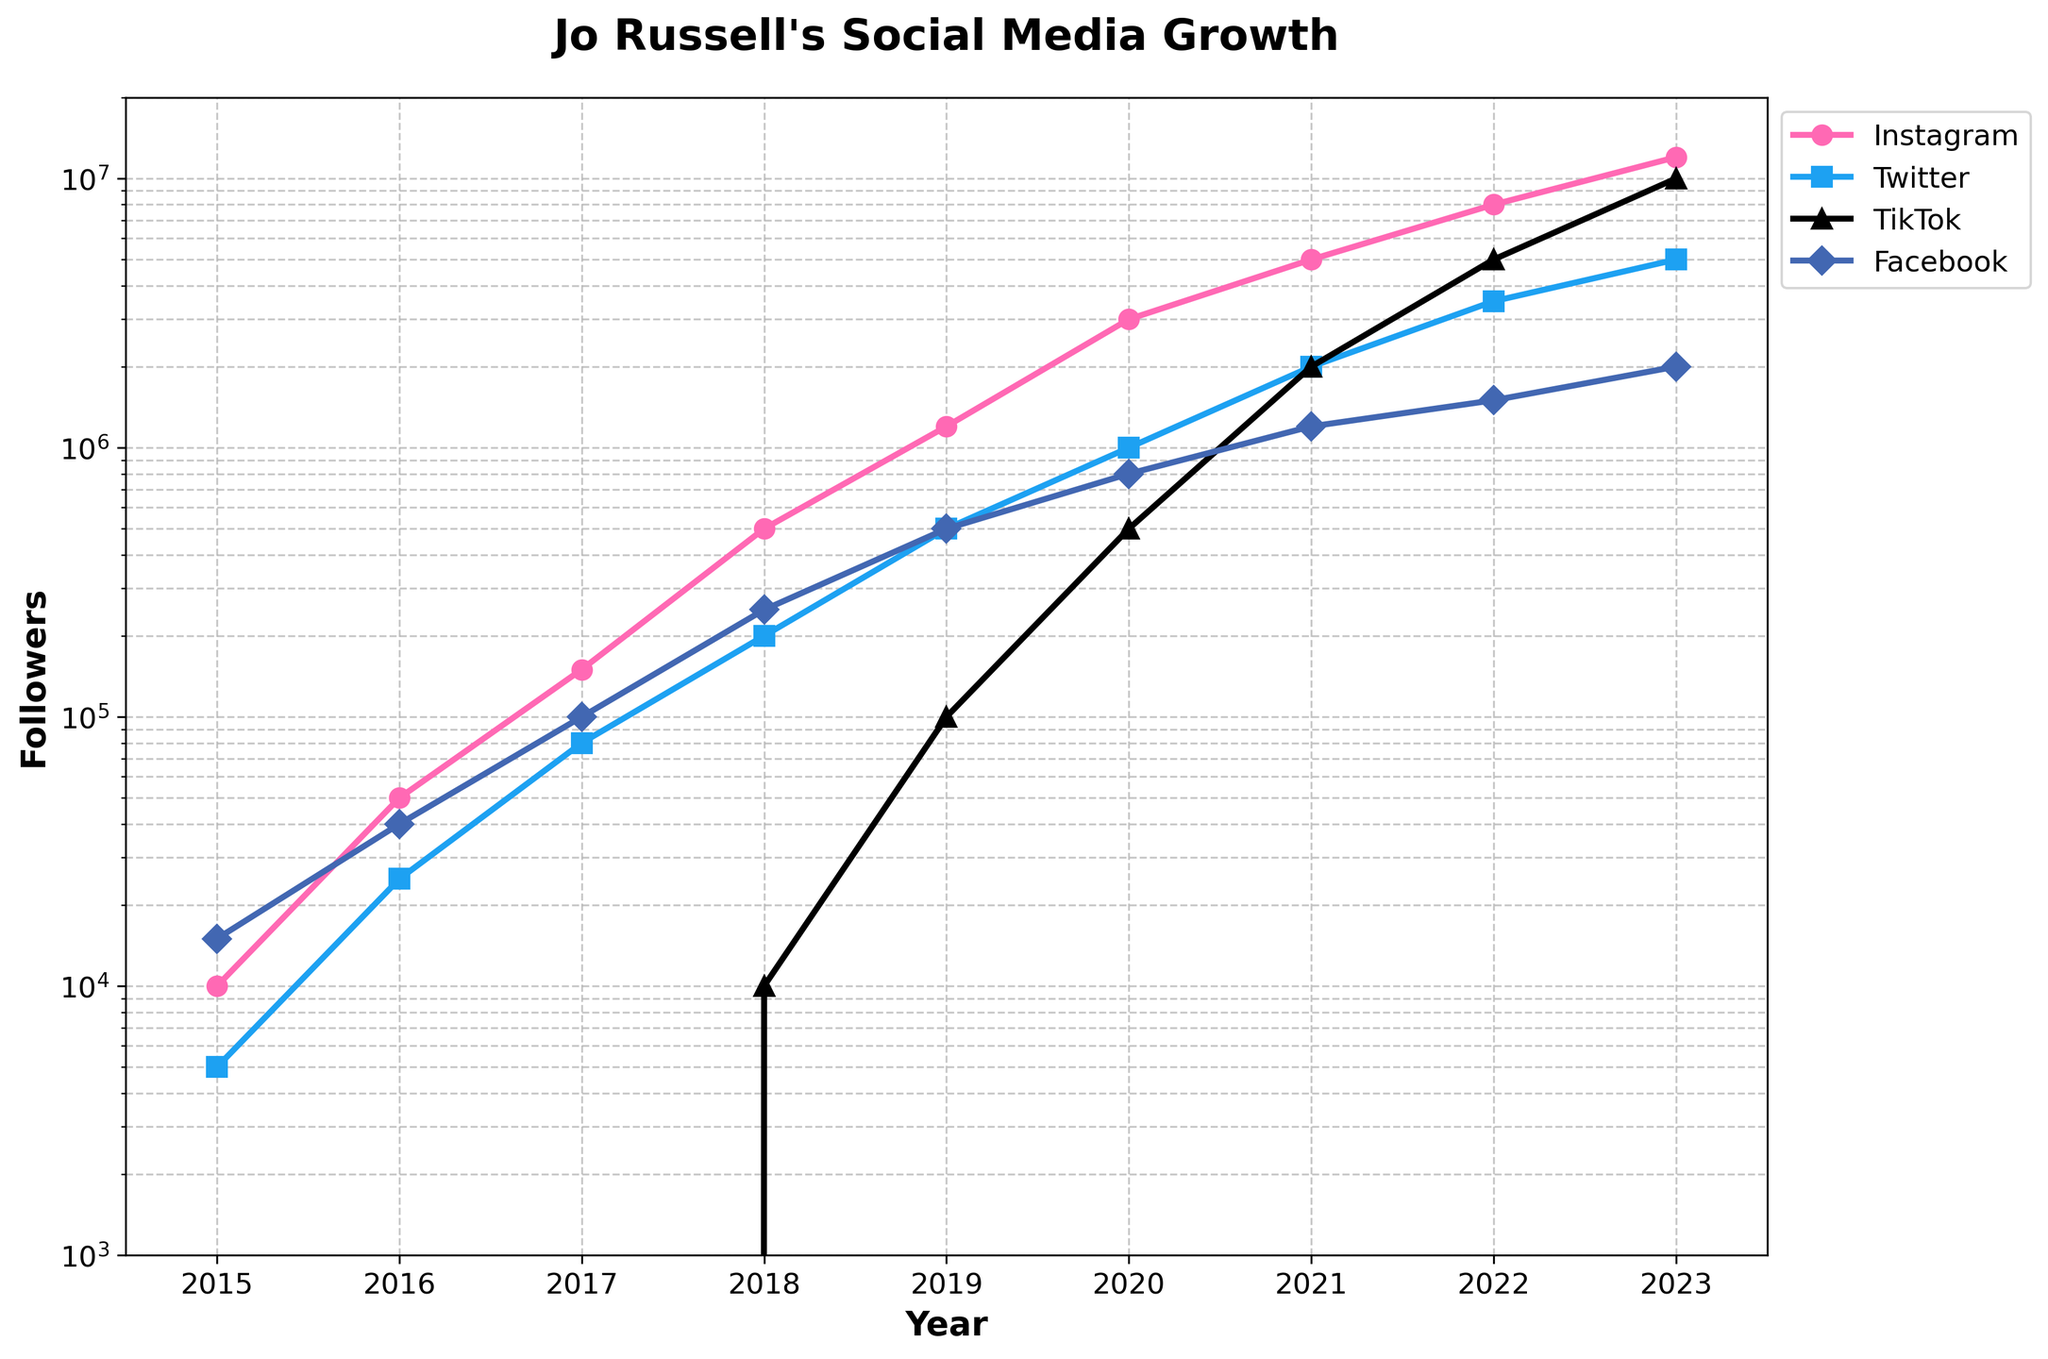what is the total number of Instagram followers Jo Russell had in 2018 and 2020 combined? In 2018, Jo had 500,000 Instagram followers, and in 2020, she had 3,000,000. Adding these together, 500,000 + 3,000,000 = 3,500,000.
Answer: 3,500,000 Which platform saw the highest follower count in 2023? In the year 2023, TikTok had the highest follower count, reaching 10,000,000 followers according to the chart.
Answer: TikTok Between Twitter and Facebook, which platform had more followers in 2019? In 2019, Twitter had 500,000 followers while Facebook had 500,000 followers, making it a tie.
Answer: Both Compare the follower growth on Instagram and TikTok from 2021 to 2023. Which platform experienced a greater increase? Instagram grew from 5,000,000 to 12,000,000, an increase of 7,000,000 followers. TikTok grew from 2,000,000 to 10,000,000, an increase of 8,000,000 followers. Therefore, TikTok experienced a greater increase.
Answer: TikTok How does the average number of Instagram followers between 2015 and 2023 compare to the average number of Facebook followers in the same period? The total Instagram followers from 2015 to 2023 is 12,000,000, and for Facebook, it is 2,000,000. The number of years is 9 for both platforms. Average Instagram followers: 12,000,000 / 9 ≈ 1,333,333. Average Facebook followers: 2,000,000 / 9 ≈ 222,222. The average number of Instagram followers is higher.
Answer: Instagram Which year showed the introduction of Jo Russell's TikTok account and what was her follower count in that year? TikTok followers started appearing in 2018 with a follower count of 10,000.
Answer: 2018, 10,000 Visual comparison: What color represents the Twitter follower growth line in the chart? The Twitter follower growth line is represented by the color blue in the chart.
Answer: Blue What year did Jo Russell's Facebook followers reach 1,500,000? In 2022, Jo Russell’s Facebook followers reached 1,500,000 according to the chart.
Answer: 2022 